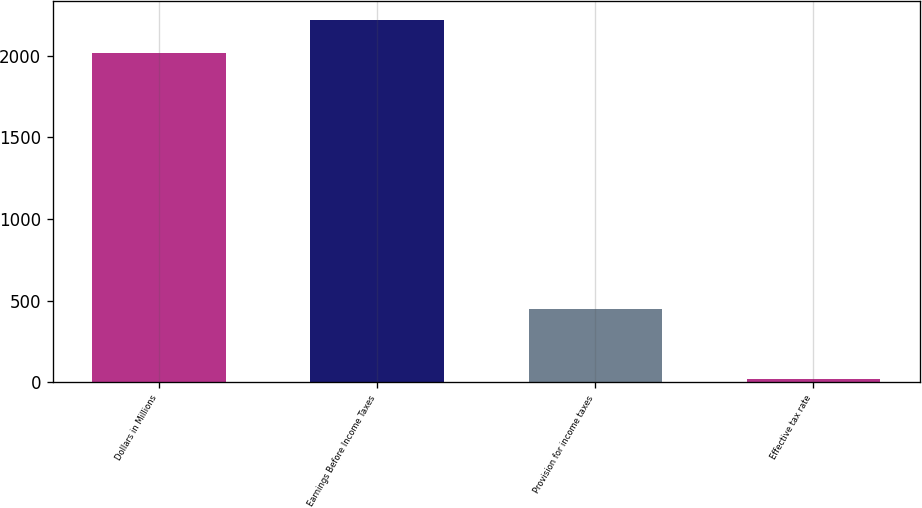Convert chart to OTSL. <chart><loc_0><loc_0><loc_500><loc_500><bar_chart><fcel>Dollars in Millions<fcel>Earnings Before Income Taxes<fcel>Provision for income taxes<fcel>Effective tax rate<nl><fcel>2015<fcel>2220.55<fcel>446<fcel>21.5<nl></chart> 